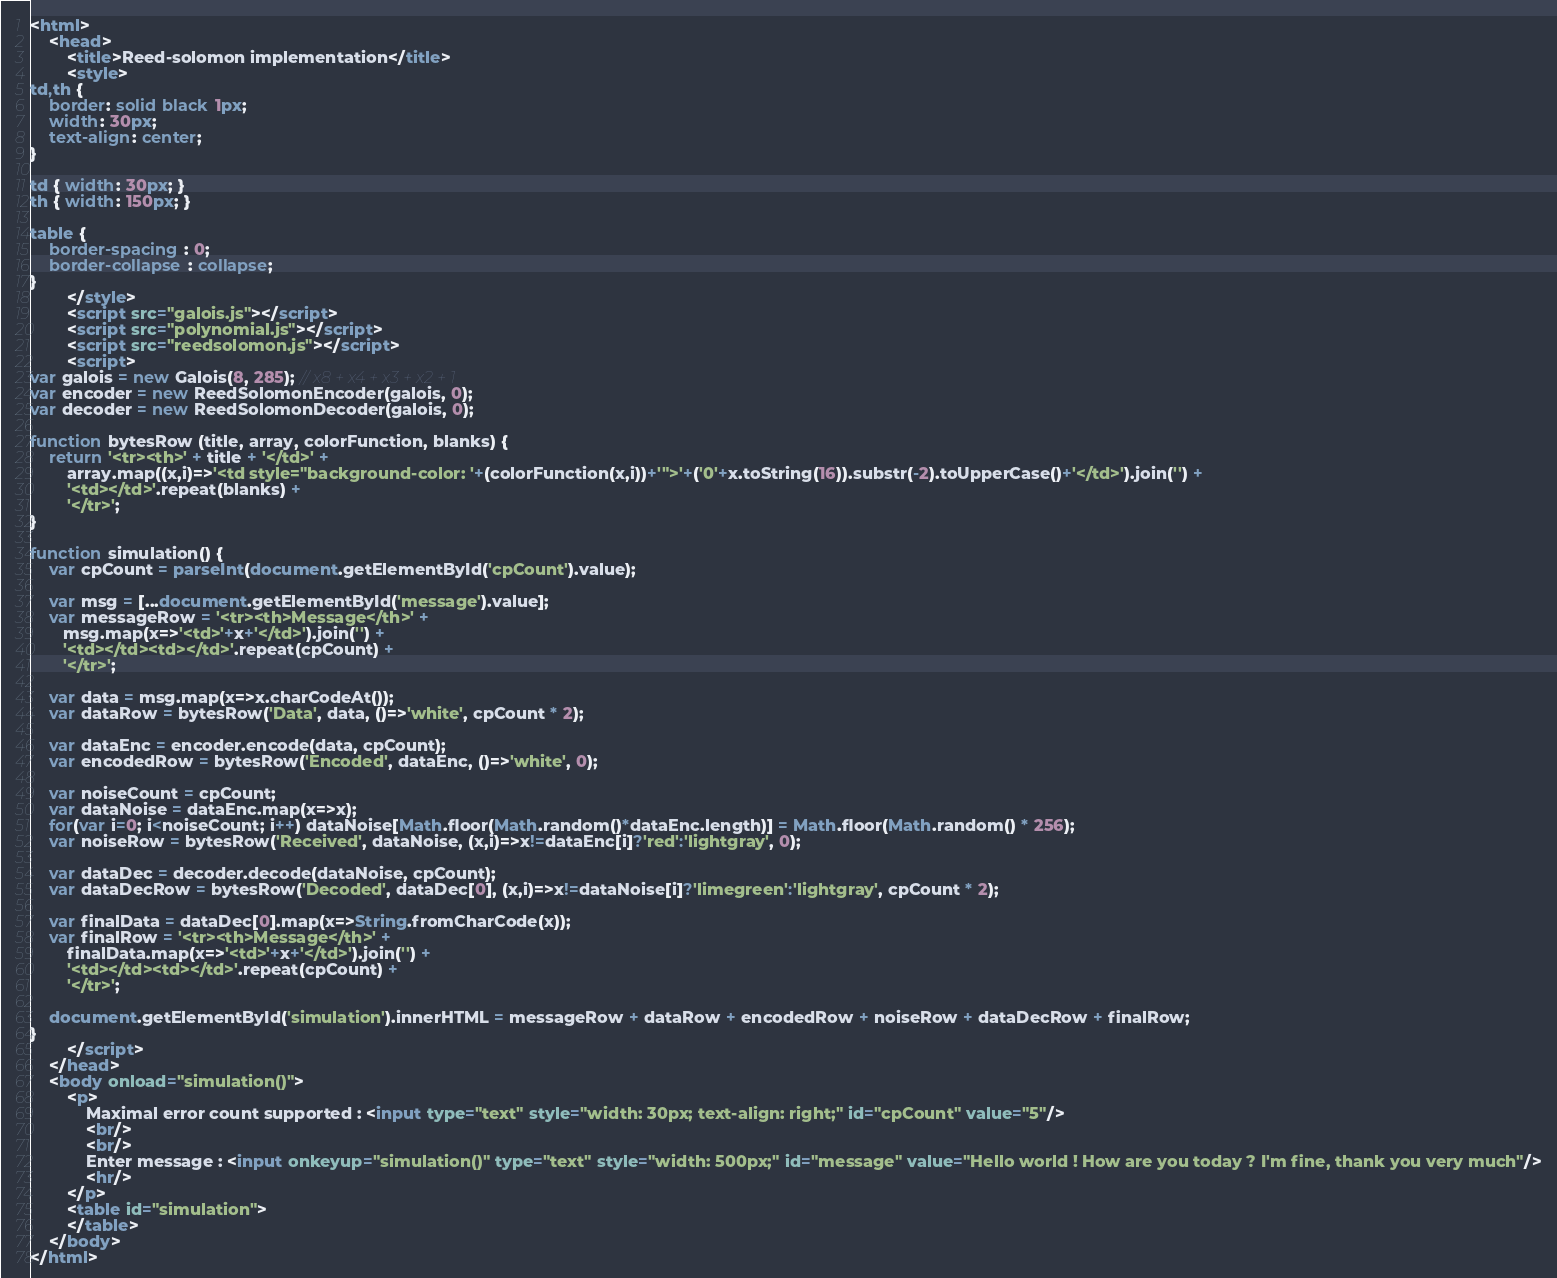<code> <loc_0><loc_0><loc_500><loc_500><_HTML_><html>
	<head>
		<title>Reed-solomon implementation</title>
		<style>
td,th {
	border: solid black 1px;
	width: 30px;
	text-align: center;
}

td { width: 30px; }
th { width: 150px; }

table {
	border-spacing : 0;
	border-collapse : collapse;
}
		</style>
		<script src="galois.js"></script>
		<script src="polynomial.js"></script>
		<script src="reedsolomon.js"></script>
		<script>
var galois = new Galois(8, 285); // x8 + x4 + x3 + x2 + 1
var encoder = new ReedSolomonEncoder(galois, 0);
var decoder = new ReedSolomonDecoder(galois, 0);

function bytesRow (title, array, colorFunction, blanks) {
	return '<tr><th>' + title + '</td>' +
		array.map((x,i)=>'<td style="background-color: '+(colorFunction(x,i))+'">'+('0'+x.toString(16)).substr(-2).toUpperCase()+'</td>').join('') +
		'<td></td>'.repeat(blanks) +
		'</tr>';
}

function simulation() {
	var cpCount = parseInt(document.getElementById('cpCount').value);
	
	var msg = [...document.getElementById('message').value];
	var messageRow = '<tr><th>Message</th>' +
	   msg.map(x=>'<td>'+x+'</td>').join('') +
	   '<td></td><td></td>'.repeat(cpCount) +
	   '</tr>';

	var data = msg.map(x=>x.charCodeAt());
	var dataRow = bytesRow('Data', data, ()=>'white', cpCount * 2);
	
	var dataEnc = encoder.encode(data, cpCount);
	var encodedRow = bytesRow('Encoded', dataEnc, ()=>'white', 0);
	
	var noiseCount = cpCount;
	var dataNoise = dataEnc.map(x=>x);
	for(var i=0; i<noiseCount; i++) dataNoise[Math.floor(Math.random()*dataEnc.length)] = Math.floor(Math.random() * 256);
	var noiseRow = bytesRow('Received', dataNoise, (x,i)=>x!=dataEnc[i]?'red':'lightgray', 0);
	
	var dataDec = decoder.decode(dataNoise, cpCount);
	var dataDecRow = bytesRow('Decoded', dataDec[0], (x,i)=>x!=dataNoise[i]?'limegreen':'lightgray', cpCount * 2);
	
	var finalData = dataDec[0].map(x=>String.fromCharCode(x));
	var finalRow = '<tr><th>Message</th>' +
		finalData.map(x=>'<td>'+x+'</td>').join('') +
		'<td></td><td></td>'.repeat(cpCount) +
		'</tr>';
	   
	document.getElementById('simulation').innerHTML = messageRow + dataRow + encodedRow + noiseRow + dataDecRow + finalRow;
}
		</script>
	</head>
	<body onload="simulation()">
		<p>
			Maximal error count supported : <input type="text" style="width: 30px; text-align: right;" id="cpCount" value="5"/>
			<br/>
			<br/>
			Enter message : <input onkeyup="simulation()" type="text" style="width: 500px;" id="message" value="Hello world ! How are you today ? I'm fine, thank you very much"/>
			<hr/>
		</p>
		<table id="simulation">
		</table>
	</body>
</html>
</code> 